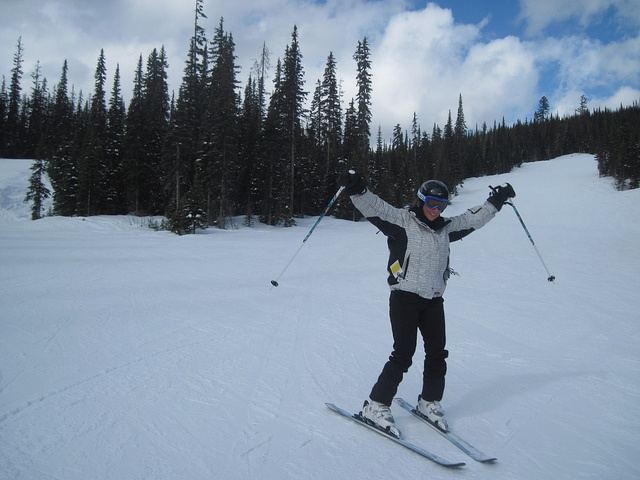Describe the objects in this image and their specific colors. I can see people in darkgray, black, and gray tones and skis in darkgray and gray tones in this image. 